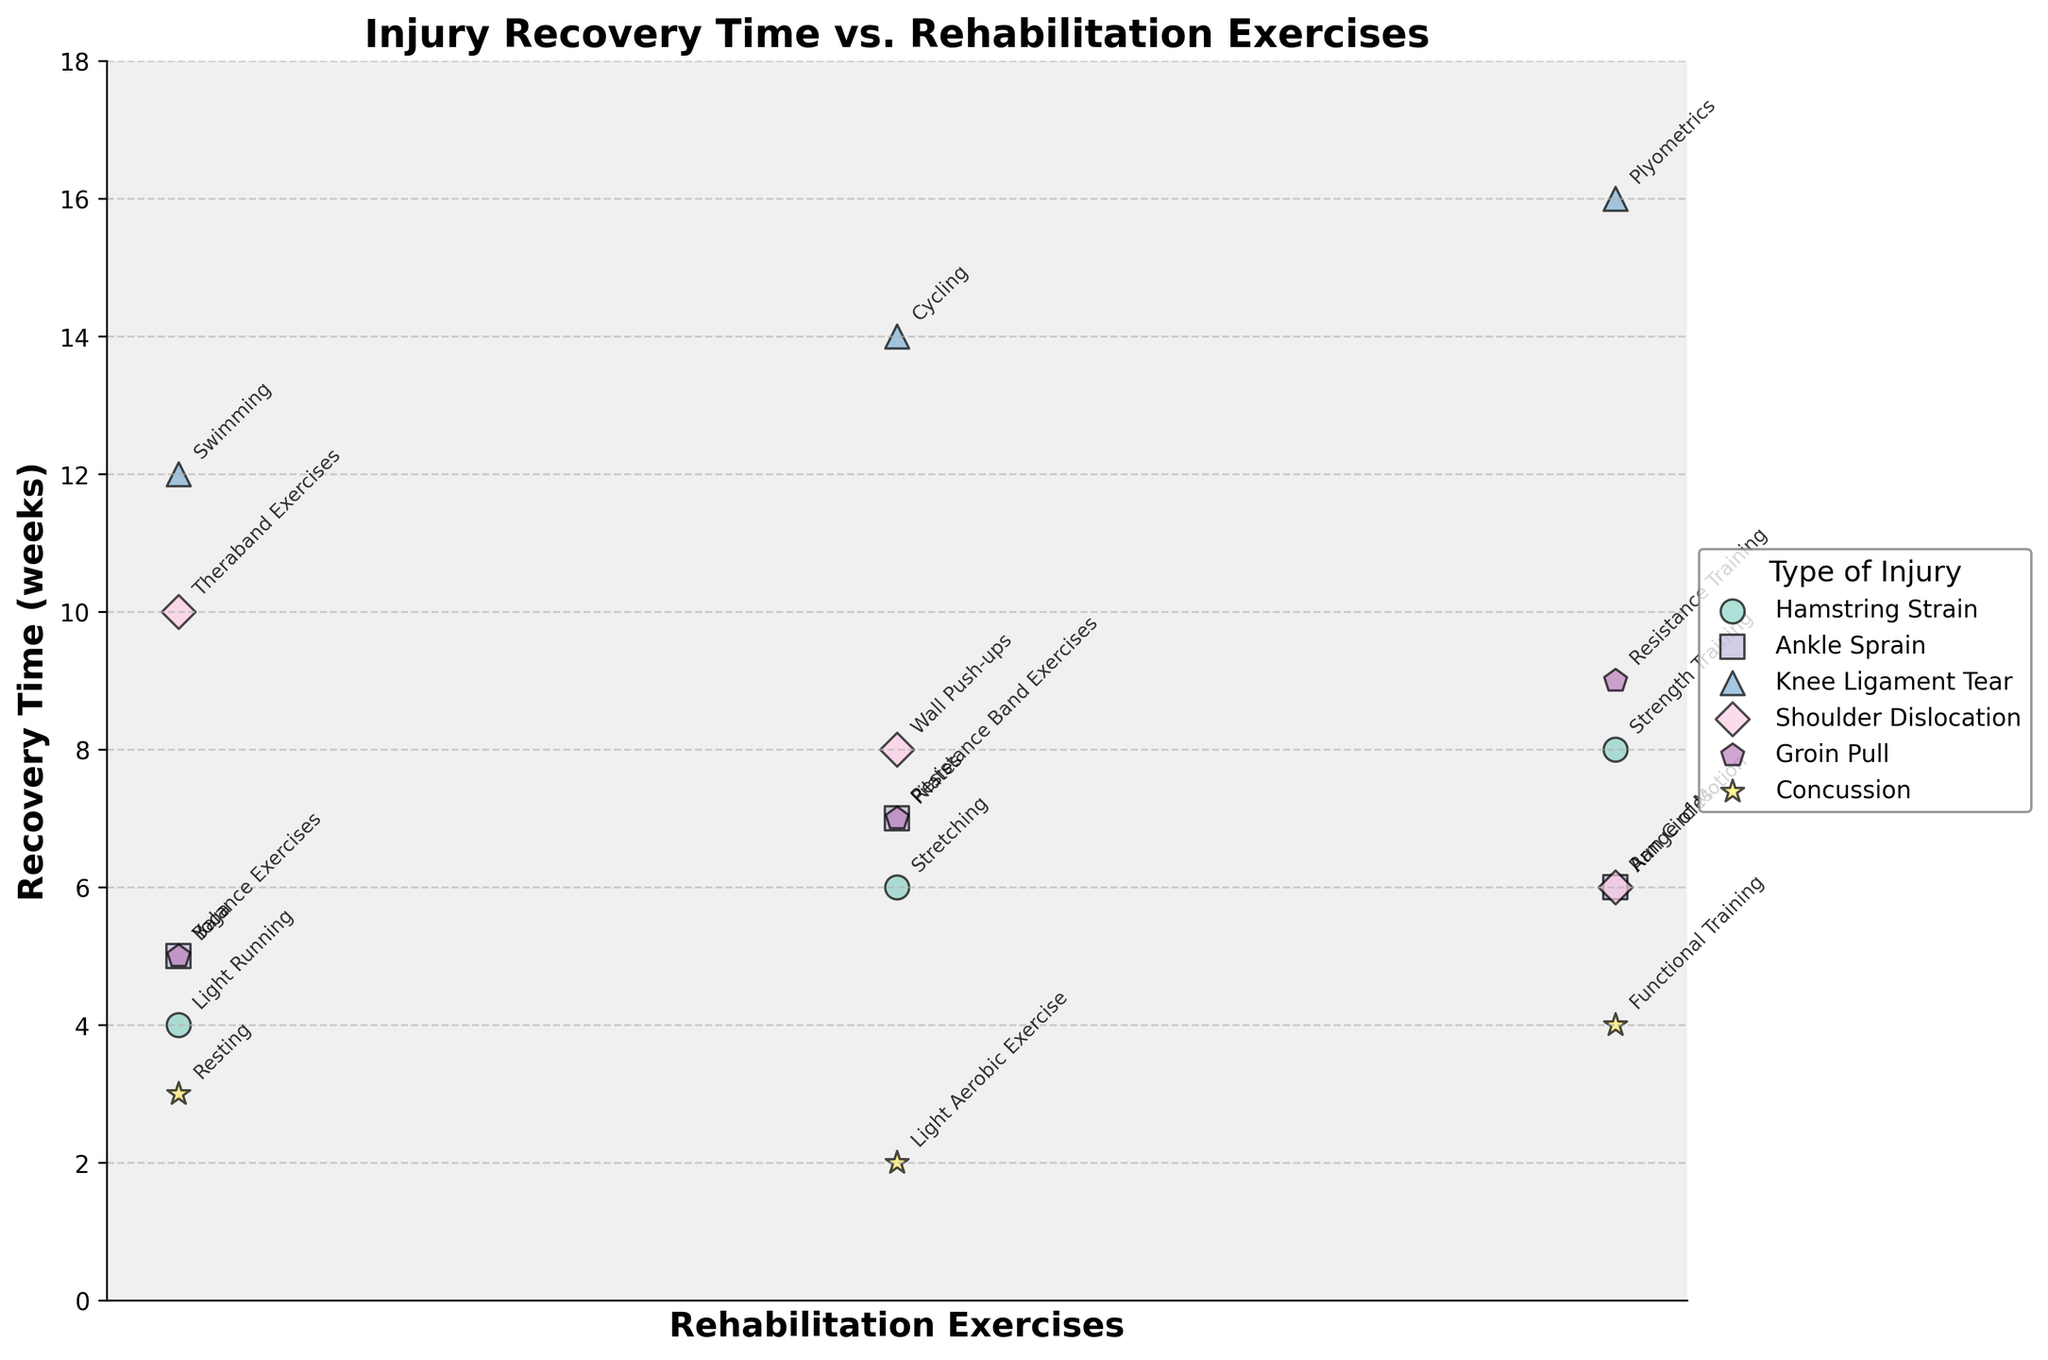what is the title of the figure? The title is usually located at the top of the figure and provides a brief description of what the figure is about. In this case, the title is written in bold.
Answer: Injury Recovery Time vs. Rehabilitation Exercises How many types of injuries are represented in the figure? By observing the legend or different colors and markers in the scatter plot, we can count the number of distinct injury types.
Answer: 6 which rehabilitation exercise has the shortest recovery time for 'Hamstring Strain'? By locating the data points for 'Hamstring Strain' (typically grouped by a specific color and marker), we can compare the recovery times and identify the shortest one.
Answer: Light Running compare the recovery times for 'Resistance Band Exercises' and 'Balance Exercises' for 'Ankle Sprain'. Which one is longer? Locate the data points for 'Ankle Sprain' grouped together, and specifically find the points for 'Resistance Band Exercises' and 'Balance Exercises'. Compare their y-values to determine which one is higher.
Answer: Resistance Band Exercises what is the average recovery time for the exercises associated with 'Groin Pull'? Identify the recovery times for all the rehabilitation exercises related to 'Groin Pull'. Sum the recovery times and divide by the number of exercises. Detailed steps:
1. Identify recovery times: 5, 7, 9 weeks.
2. Sum them: 5 + 7 + 9 = 21.
3. Divide by the number of exercises: 21 / 3 = 7.
Answer: 7 what is the range of recovery times for 'Knee Ligament Tear'? The range is calculated by finding the difference between the maximum and minimum recovery time for 'Knee Ligament Tear'. 
- Identify recovery times: 12, 14, 16 weeks.
- Maximum = 16, Minimum = 12.
- Range = 16 - 12.
Answer: 4 How does the average recovery time for 'Hamstring Strain' compare to 'Shoulder Dislocation'? Calculate the average recovery time for both injury types and compare them. Detailed steps:
1. 'Hamstring Strain': (4 + 6 + 8) / 3 = 18 / 3 = 6.
2. 'Shoulder Dislocation': (6 + 8 + 10) / 3 = 24 / 3 = 8.
3. Compare the two averages: 8 > 6
Answer: Shoulder Dislocation has a longer average recovery time Which exercise had the maximum recovery time for 'Knee Ligament Tear' and what is that time? Find the data points for 'Knee Ligament Tear' and identify which exercise has the highest y-value.
Answer: Plyometrics; 16 weeks For which injury is 'Resting' a rehabilitation exercise and what is its recovery time? Identify the data point associated with the exercise 'Resting' and note its corresponding injury and recovery time.
Answer: Concussion; 3 weeks 